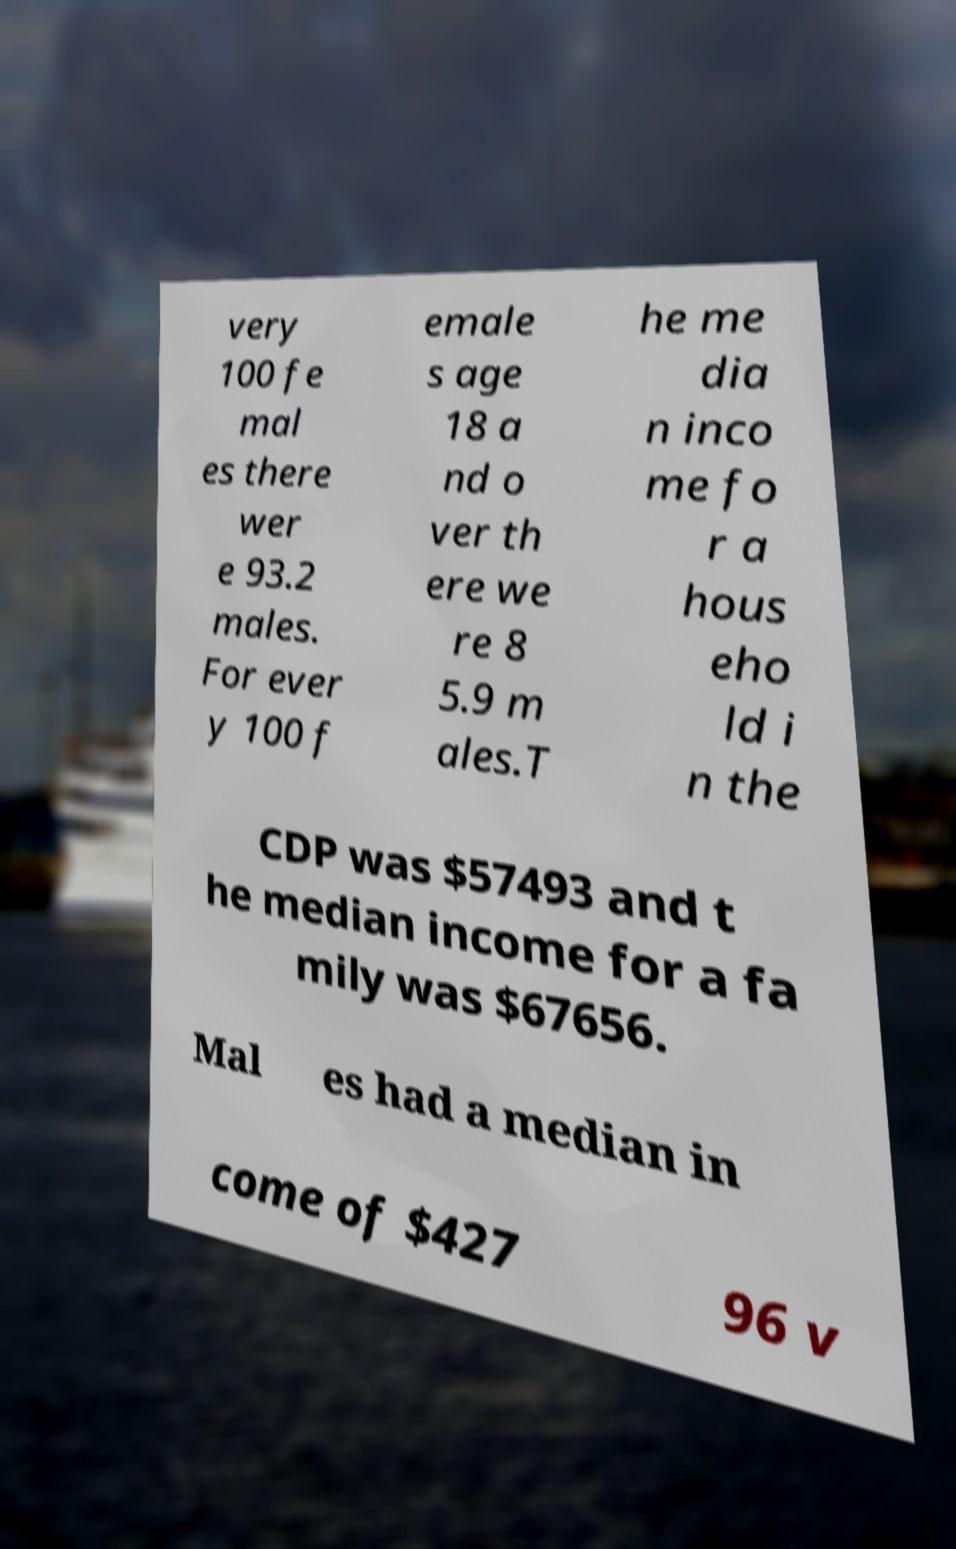Could you extract and type out the text from this image? very 100 fe mal es there wer e 93.2 males. For ever y 100 f emale s age 18 a nd o ver th ere we re 8 5.9 m ales.T he me dia n inco me fo r a hous eho ld i n the CDP was $57493 and t he median income for a fa mily was $67656. Mal es had a median in come of $427 96 v 